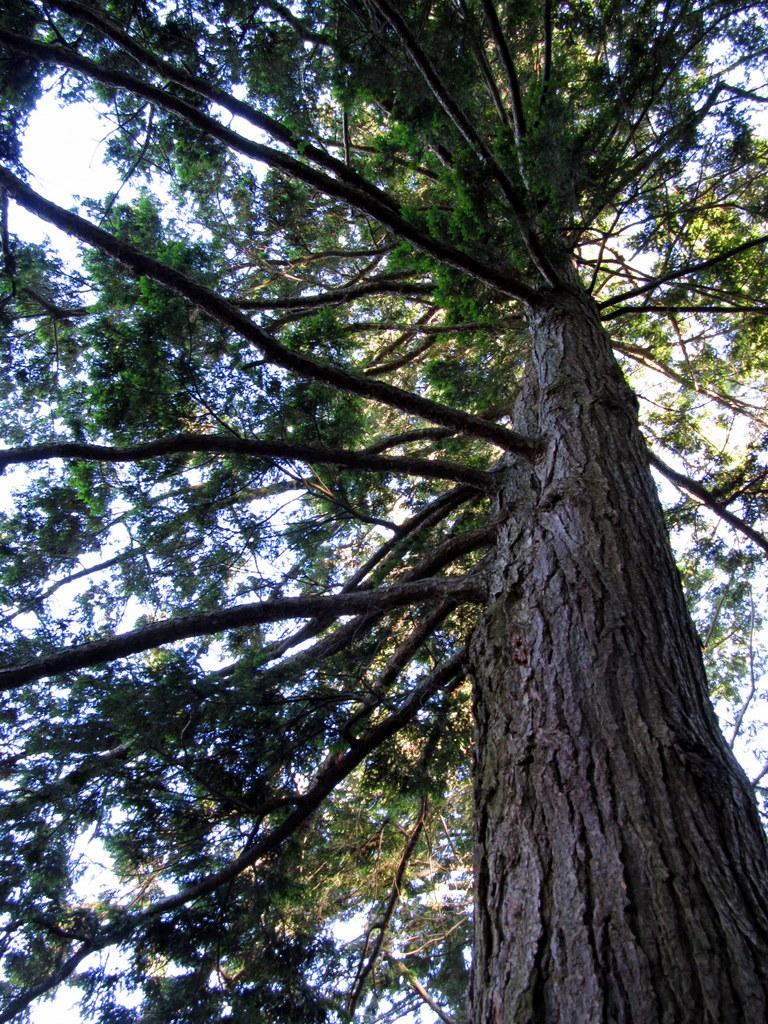What type of plant can be seen in the image? There is a tree in the image. What parts of the tree are visible? Some branches of the tree are visible. What is visible in the background of the image? The sky is visible in the image. How many brothers are depicted in the image? There are no brothers present in the image; it features a tree and the sky. 